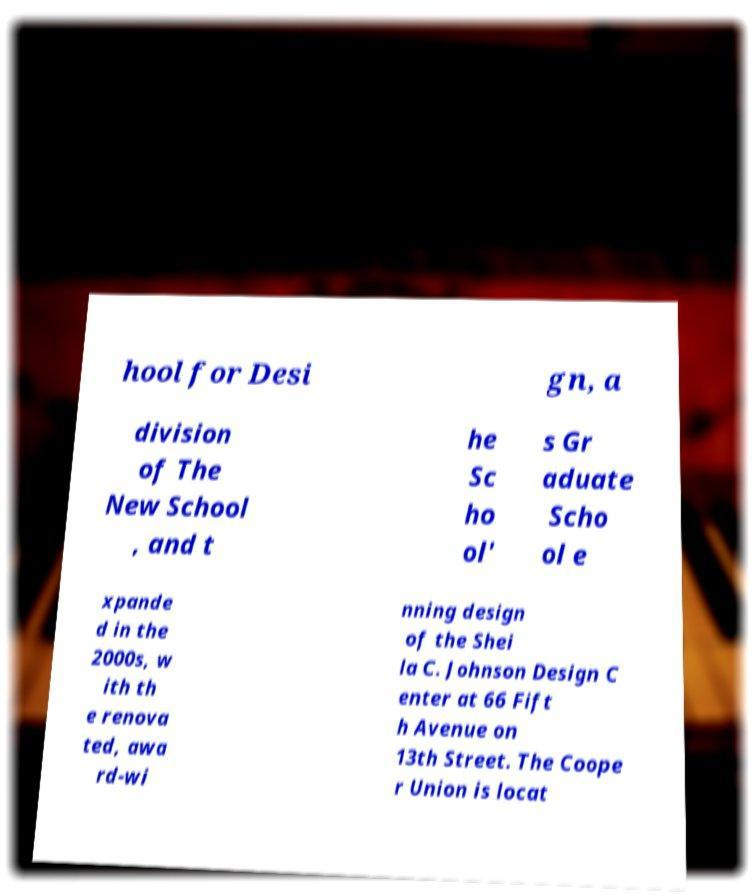Can you accurately transcribe the text from the provided image for me? hool for Desi gn, a division of The New School , and t he Sc ho ol' s Gr aduate Scho ol e xpande d in the 2000s, w ith th e renova ted, awa rd-wi nning design of the Shei la C. Johnson Design C enter at 66 Fift h Avenue on 13th Street. The Coope r Union is locat 